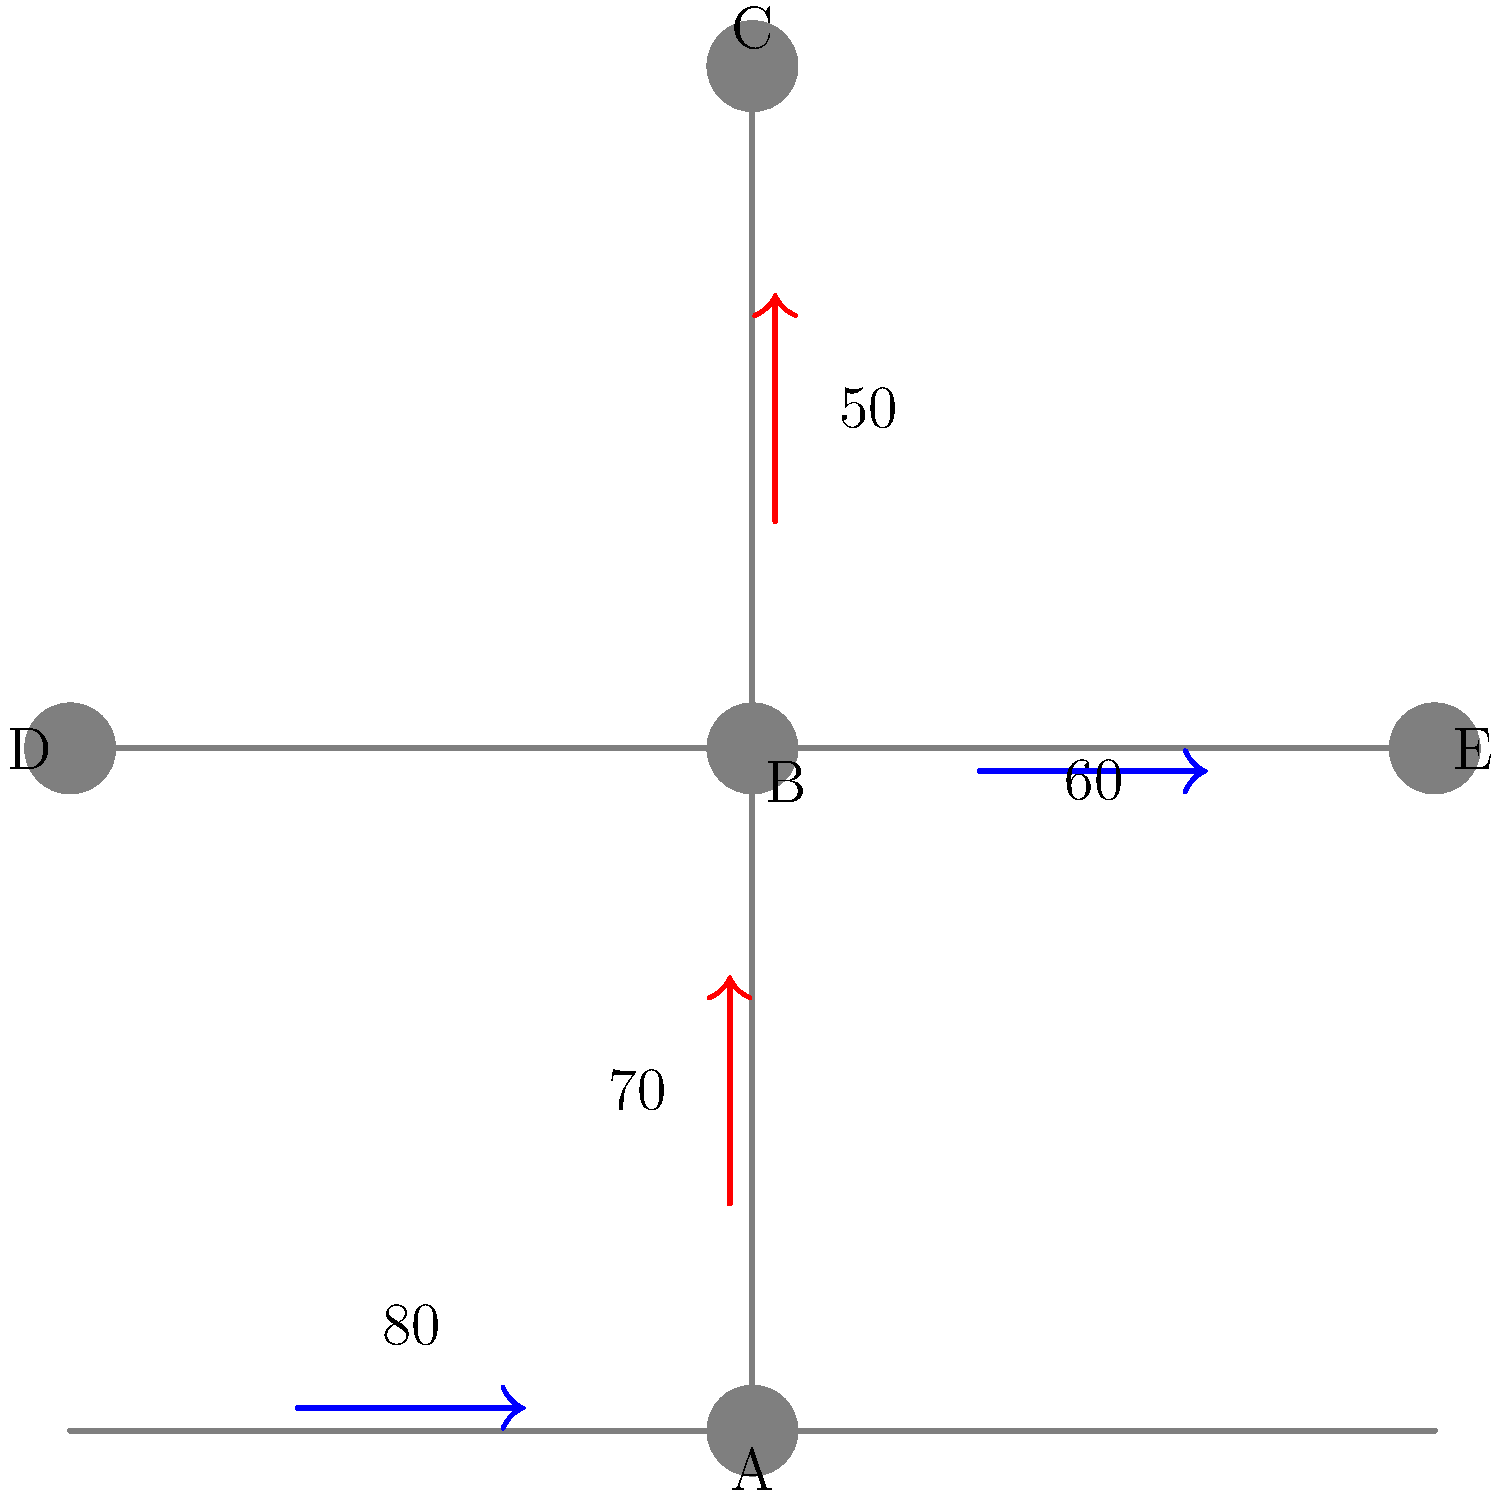Given the city traffic flow diagram, which shows vehicle densities (vehicles per hour) and flow directions at various intersections, determine the total number of vehicles passing through intersection B per hour. Assume that all vehicles passing through B continue their journey without turning. To solve this problem, we need to follow these steps:

1. Identify the flows entering and exiting intersection B:
   - From A to B: 80 vehicles/hour (moving north)
   - From D to B: 60 vehicles/hour (moving east)
   - From B to C: 50 vehicles/hour (moving north)
   - From B to E: 70 vehicles/hour (moving east)

2. Calculate the total number of vehicles entering B:
   $\text{Vehicles entering B} = 80 + 60 = 140 \text{ vehicles/hour}$

3. Calculate the total number of vehicles exiting B:
   $\text{Vehicles exiting B} = 50 + 70 = 120 \text{ vehicles/hour}$

4. The total number of vehicles passing through B is the average of vehicles entering and exiting:
   $$\text{Total vehicles passing through B} = \frac{\text{Vehicles entering B} + \text{Vehicles exiting B}}{2}$$
   $$= \frac{140 + 120}{2} = \frac{260}{2} = 130 \text{ vehicles/hour}$$

This approach assumes a steady-state flow where the number of vehicles entering and exiting the intersection over time is balanced.
Answer: 130 vehicles/hour 